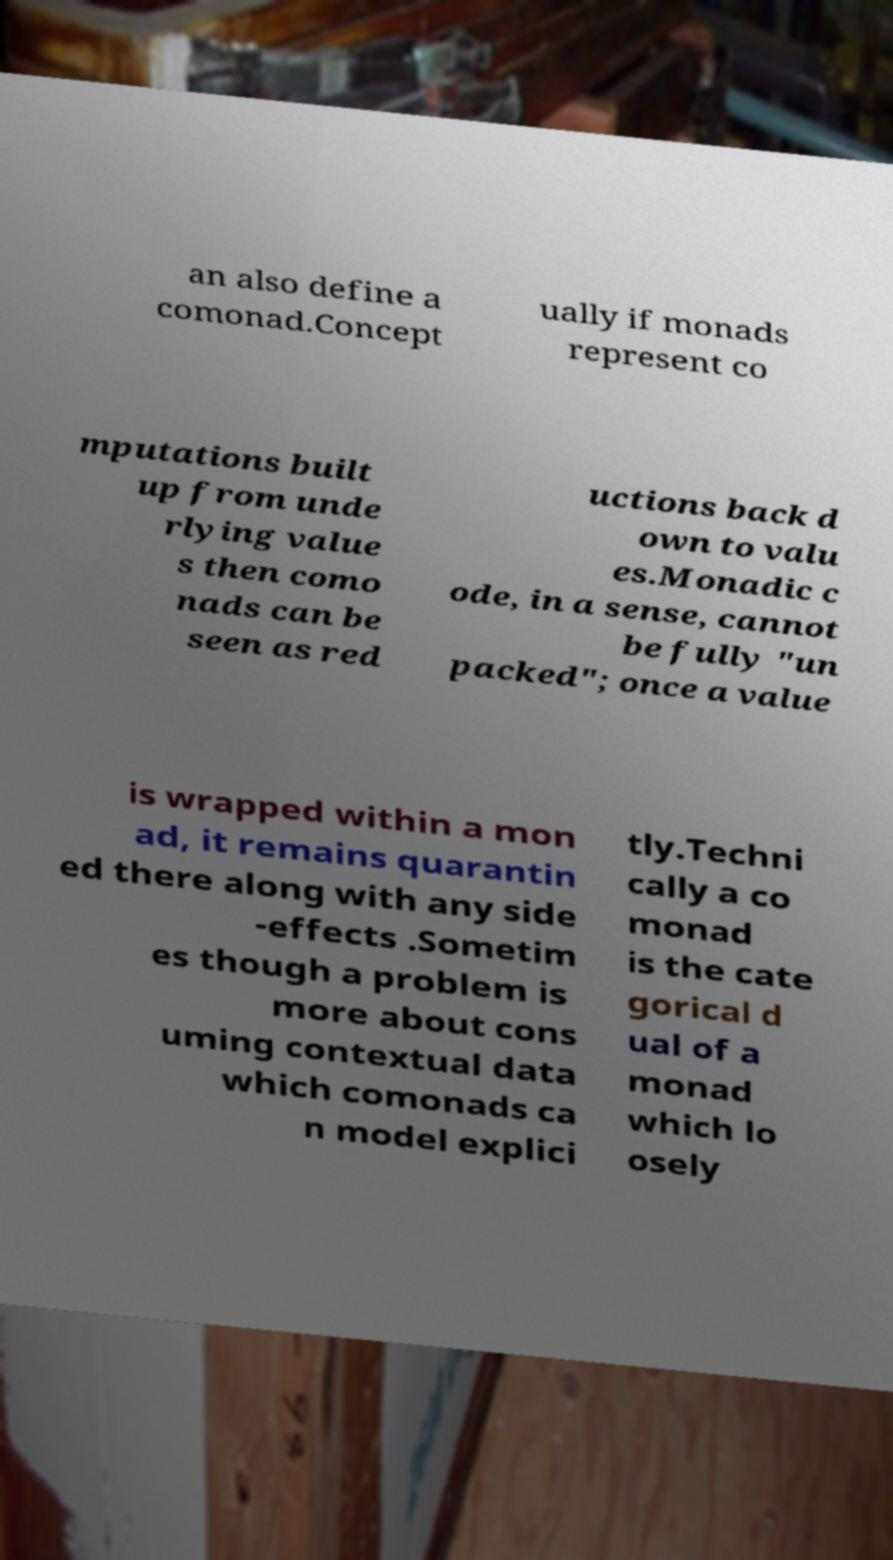There's text embedded in this image that I need extracted. Can you transcribe it verbatim? an also define a comonad.Concept ually if monads represent co mputations built up from unde rlying value s then como nads can be seen as red uctions back d own to valu es.Monadic c ode, in a sense, cannot be fully "un packed"; once a value is wrapped within a mon ad, it remains quarantin ed there along with any side -effects .Sometim es though a problem is more about cons uming contextual data which comonads ca n model explici tly.Techni cally a co monad is the cate gorical d ual of a monad which lo osely 